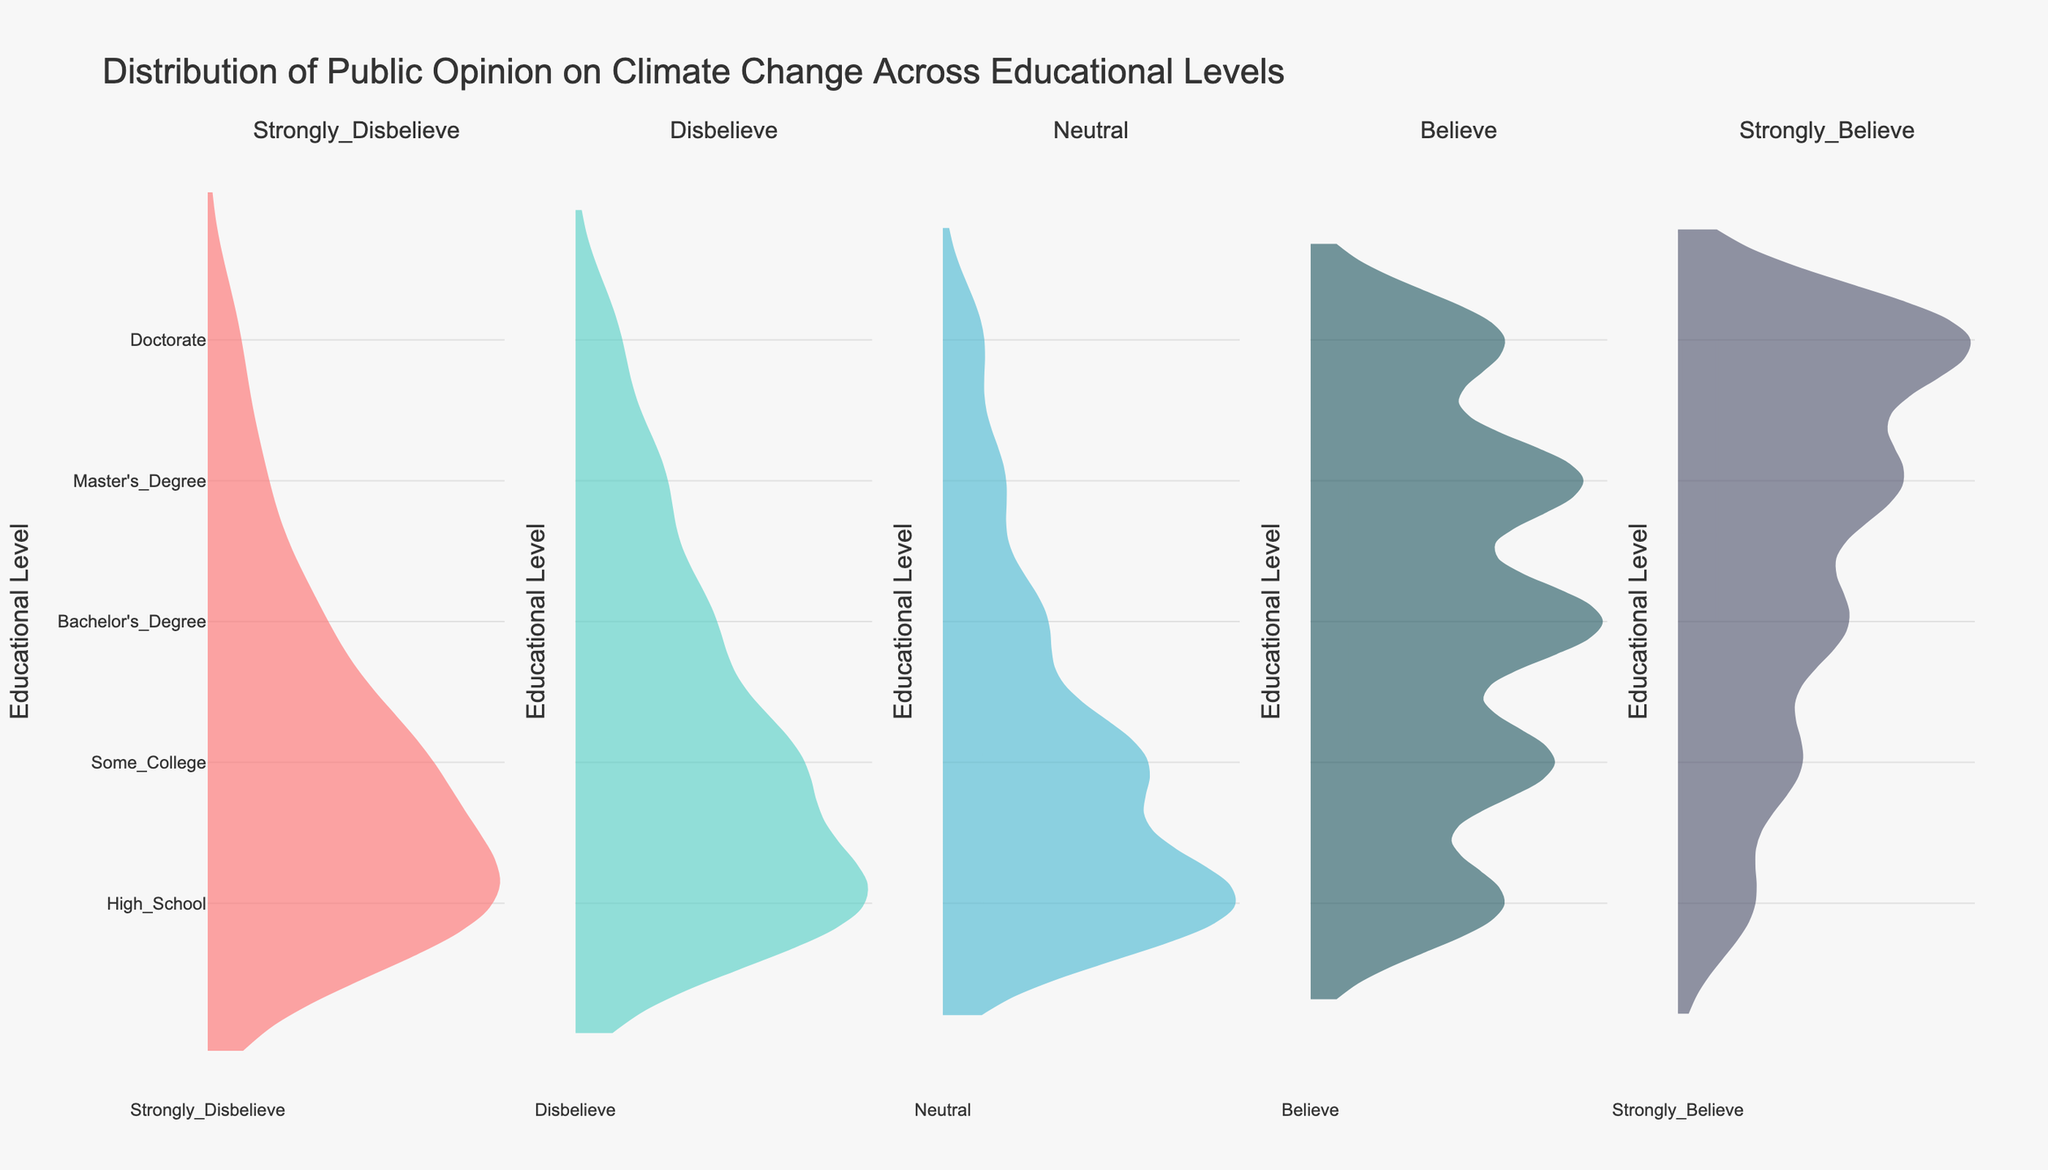What's the title of the figure? The title is located at the top of the figure and is generally larger in font size. In this case, it reads, "Distribution of Public Opinion on Climate Change Across Educational Levels."
Answer: Distribution of Public Opinion on Climate Change Across Educational Levels What does the y-axis represent? The y-axis title can usually be found along the vertical axis. It reads "Educational Level," which indicates that the levels of education are plotted along this axis.
Answer: Educational Level Which educational level has the most people who strongly believe in climate change? Look at the "Strongly Believe" subplot and observe the density of data points across different educational levels. The distribution is highest for those with a Doctorate.
Answer: Doctorate How does the trend in belief change as educational level increases? Observe the subplots and how the distributions shift across educational levels. As educational level increases, there is a trend of fewer people in disbelief and more people in strong belief about climate change.
Answer: Increases Which two educational levels have the highest number of neutral opinions about climate change? Check the "Neutral" subplot and compare the density of data points for each educational level. High School and Some College have the highest number of neutral opinions.
Answer: High School and Some College What is the least common opinion among people with a Master's Degree? Look at the violin plot for the Master's Degree row and identify which category (subplot) has the least density. "Strongly Disbelieve" has the least density.
Answer: Strongly Disbelieve Which category shows a stark increase in belief from Bachelor's Degree to Doctorate? Observe each subplot for "Believe" for both Bachelor's Degree and Doctorate levels. The density significantly increases from Bachelor's Degree to Doctorate in "Strongly Believe."
Answer: Strongly Believe How do the opinions of people with a High School education compare to those with a Doctorate? Compare the distributions for both educational levels across all subplots. People with a High School education tend to be more neutral or disbelieving, while those with a Doctorate lean towards belief and strong belief.
Answer: More neutral and disbelieving for High School, more believing for Doctorate What's the average number of people who believe and strongly believe in climate change with a Bachelor's Degree? To find the average, first sum the number of people who believe (300) and strongly believe (110) for Bachelor's Degree, then divide by 2. (300 + 110) / 2 = 205
Answer: 205 